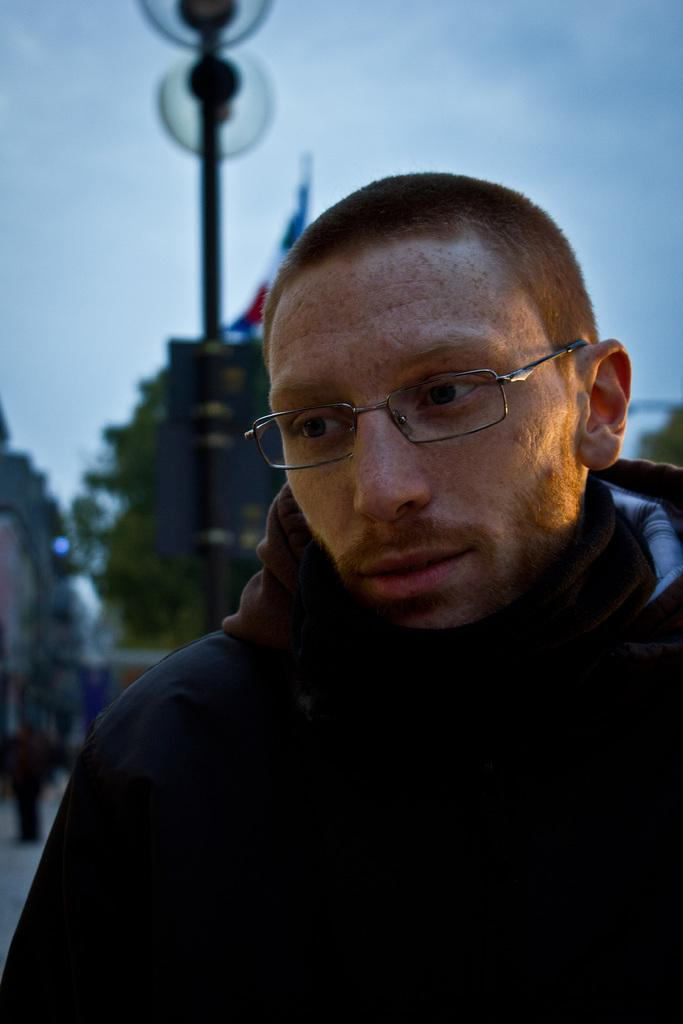Who is the main subject in the front of the image? There is a man in the front of the image. What can be seen in the background of the image? There is a pole in the background of the image. What is attached to the pole? There is a flag on the pole. What is the color of the object that the flag is on? The flag is on an object that is black in color. How would you describe the weather based on the image? The sky is cloudy in the image. What caption is written on the flag in the image? There is no caption visible on the flag in the image. What arithmetic problem is the man solving in the image? There is no indication in the image that the man is solving an arithmetic problem. 